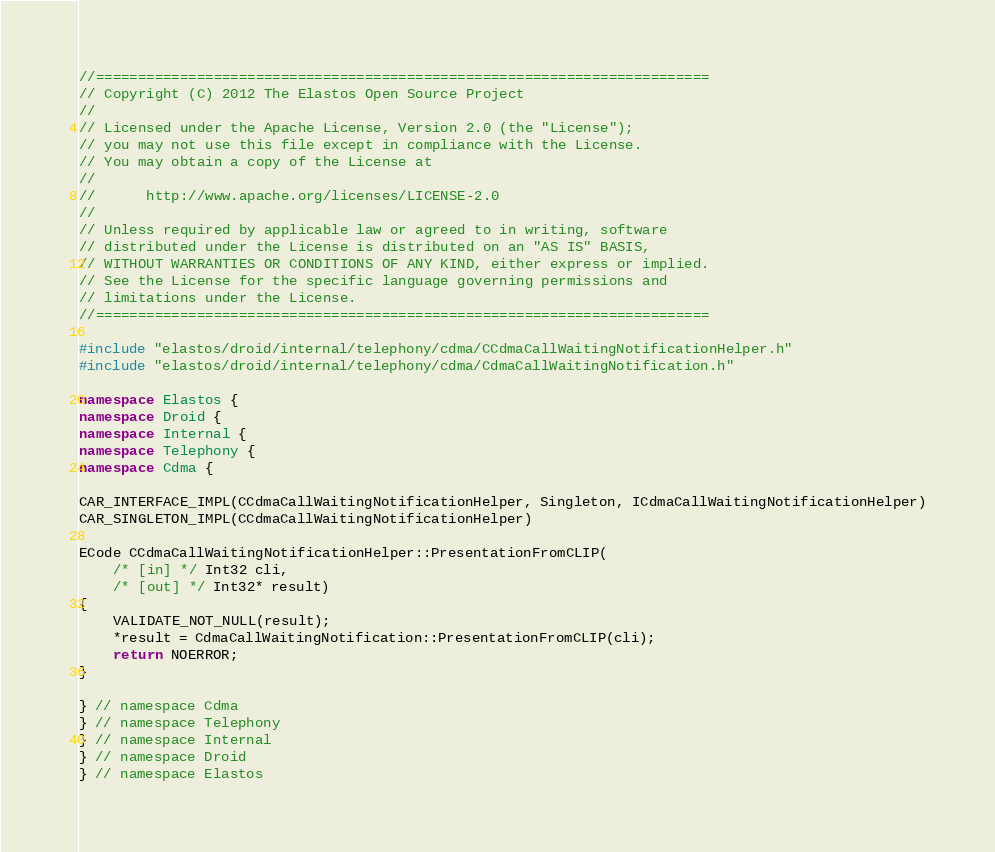Convert code to text. <code><loc_0><loc_0><loc_500><loc_500><_C++_>//=========================================================================
// Copyright (C) 2012 The Elastos Open Source Project
//
// Licensed under the Apache License, Version 2.0 (the "License");
// you may not use this file except in compliance with the License.
// You may obtain a copy of the License at
//
//      http://www.apache.org/licenses/LICENSE-2.0
//
// Unless required by applicable law or agreed to in writing, software
// distributed under the License is distributed on an "AS IS" BASIS,
// WITHOUT WARRANTIES OR CONDITIONS OF ANY KIND, either express or implied.
// See the License for the specific language governing permissions and
// limitations under the License.
//=========================================================================

#include "elastos/droid/internal/telephony/cdma/CCdmaCallWaitingNotificationHelper.h"
#include "elastos/droid/internal/telephony/cdma/CdmaCallWaitingNotification.h"

namespace Elastos {
namespace Droid {
namespace Internal {
namespace Telephony {
namespace Cdma {

CAR_INTERFACE_IMPL(CCdmaCallWaitingNotificationHelper, Singleton, ICdmaCallWaitingNotificationHelper)
CAR_SINGLETON_IMPL(CCdmaCallWaitingNotificationHelper)

ECode CCdmaCallWaitingNotificationHelper::PresentationFromCLIP(
    /* [in] */ Int32 cli,
    /* [out] */ Int32* result)
{
    VALIDATE_NOT_NULL(result);
    *result = CdmaCallWaitingNotification::PresentationFromCLIP(cli);
    return NOERROR;
}

} // namespace Cdma
} // namespace Telephony
} // namespace Internal
} // namespace Droid
} // namespace Elastos
</code> 